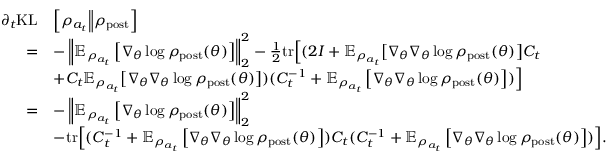<formula> <loc_0><loc_0><loc_500><loc_500>\begin{array} { r l } { \partial _ { t } { K L } } & { \Big [ \rho _ { a _ { t } } \Big \| \rho _ { p o s t } \Big ] } \\ { = } & { - \left \| \mathbb { E } _ { \rho _ { a _ { t } } } \left [ \nabla _ { \theta } \log \rho _ { p o s t } ( \theta ) \right ] \right \| _ { 2 } ^ { 2 } - \frac { 1 } { 2 } t r \Big [ ( 2 I + \mathbb { E } _ { \rho _ { a _ { t } } } \Big [ \nabla _ { \theta } \nabla _ { \theta } \log \rho _ { p o s t } ( \theta ) \Big ] C _ { t } } \\ & { + C _ { t } \mathbb { E } _ { \rho _ { a _ { t } } } \Big [ \nabla _ { \theta } \nabla _ { \theta } \log \rho _ { p o s t } ( \theta ) \Big ] ) ( C _ { t } ^ { - 1 } + \mathbb { E } _ { \rho _ { a _ { t } } } \left [ \nabla _ { \theta } \nabla _ { \theta } \log \rho _ { p o s t } ( \theta ) \right ] ) \Big ] } \\ { = } & { - \left \| \mathbb { E } _ { \rho _ { a _ { t } } } \left [ \nabla _ { \theta } \log \rho _ { p o s t } ( \theta ) \right ] \right \| _ { 2 } ^ { 2 } } \\ & { - t r \Big [ ( C _ { t } ^ { - 1 } + \mathbb { E } _ { \rho _ { a _ { t } } } \left [ \nabla _ { \theta } \nabla _ { \theta } \log \rho _ { p o s t } ( \theta ) \right ] ) C _ { t } ( C _ { t } ^ { - 1 } + \mathbb { E } _ { \rho _ { a _ { t } } } \left [ \nabla _ { \theta } \nabla _ { \theta } \log \rho _ { p o s t } ( \theta ) \right ] ) \Big ] . } \end{array}</formula> 